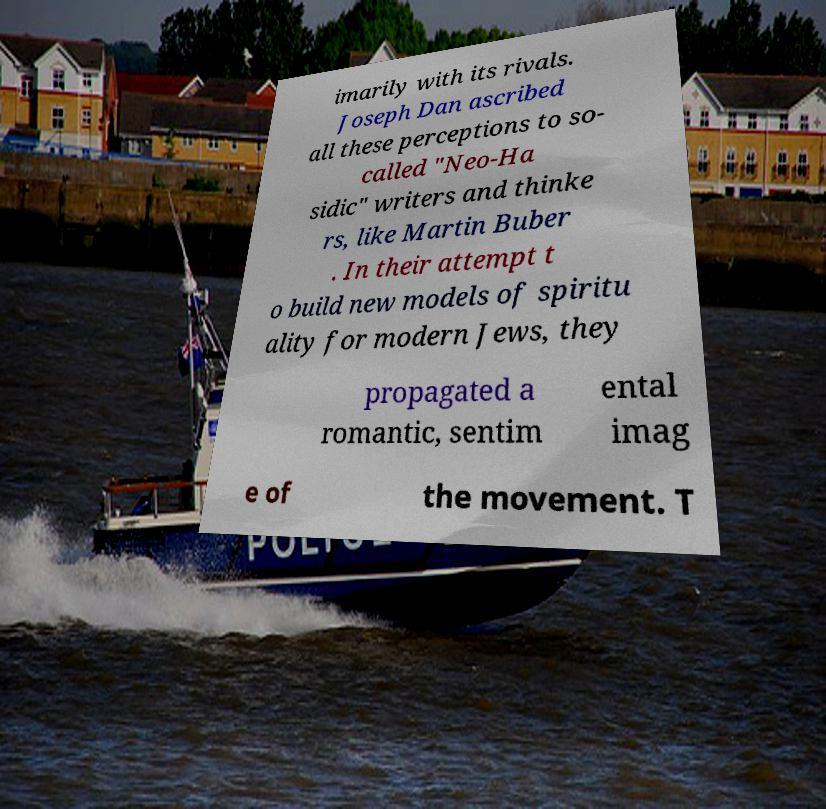Could you extract and type out the text from this image? imarily with its rivals. Joseph Dan ascribed all these perceptions to so- called "Neo-Ha sidic" writers and thinke rs, like Martin Buber . In their attempt t o build new models of spiritu ality for modern Jews, they propagated a romantic, sentim ental imag e of the movement. T 